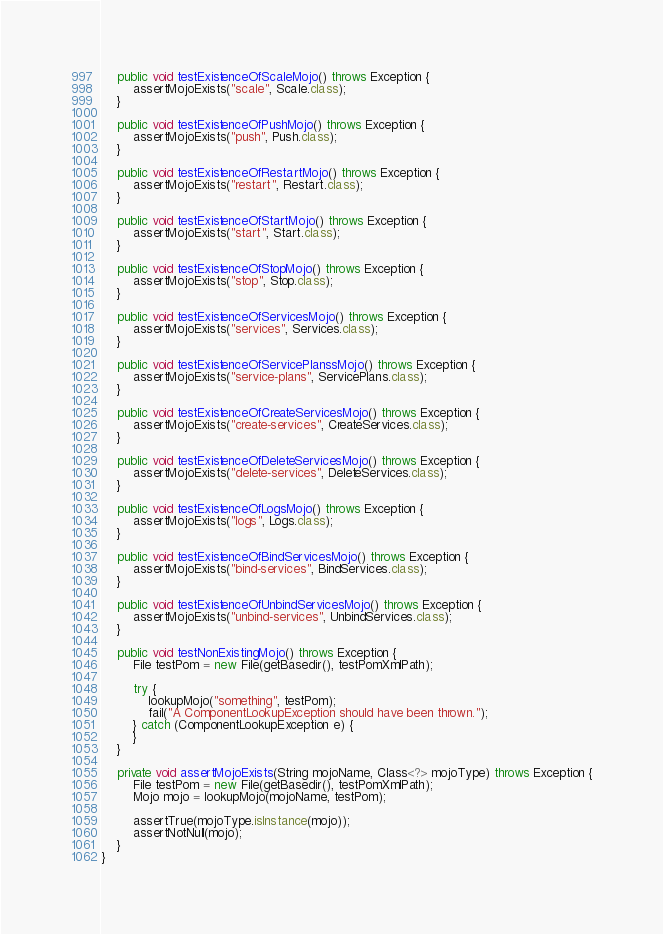<code> <loc_0><loc_0><loc_500><loc_500><_Java_>	public void testExistenceOfScaleMojo() throws Exception {
		assertMojoExists("scale", Scale.class);
	}

	public void testExistenceOfPushMojo() throws Exception {
		assertMojoExists("push", Push.class);
	}

	public void testExistenceOfRestartMojo() throws Exception {
		assertMojoExists("restart", Restart.class);
	}

	public void testExistenceOfStartMojo() throws Exception {
		assertMojoExists("start", Start.class);
	}

	public void testExistenceOfStopMojo() throws Exception {
		assertMojoExists("stop", Stop.class);
	}

	public void testExistenceOfServicesMojo() throws Exception {
		assertMojoExists("services", Services.class);
	}

	public void testExistenceOfServicePlanssMojo() throws Exception {
		assertMojoExists("service-plans", ServicePlans.class);
	}

	public void testExistenceOfCreateServicesMojo() throws Exception {
		assertMojoExists("create-services", CreateServices.class);
	}

	public void testExistenceOfDeleteServicesMojo() throws Exception {
		assertMojoExists("delete-services", DeleteServices.class);
	}

	public void testExistenceOfLogsMojo() throws Exception {
		assertMojoExists("logs", Logs.class);
	}

	public void testExistenceOfBindServicesMojo() throws Exception {
		assertMojoExists("bind-services", BindServices.class);
	}

	public void testExistenceOfUnbindServicesMojo() throws Exception {
		assertMojoExists("unbind-services", UnbindServices.class);
	}

	public void testNonExistingMojo() throws Exception {
		File testPom = new File(getBasedir(), testPomXmlPath);

		try {
			lookupMojo("something", testPom);
			fail("A ComponentLookupException should have been thrown.");
		} catch (ComponentLookupException e) {
		}
	}

	private void assertMojoExists(String mojoName, Class<?> mojoType) throws Exception {
		File testPom = new File(getBasedir(), testPomXmlPath);
		Mojo mojo = lookupMojo(mojoName, testPom);

		assertTrue(mojoType.isInstance(mojo));
		assertNotNull(mojo);
	}
}
</code> 